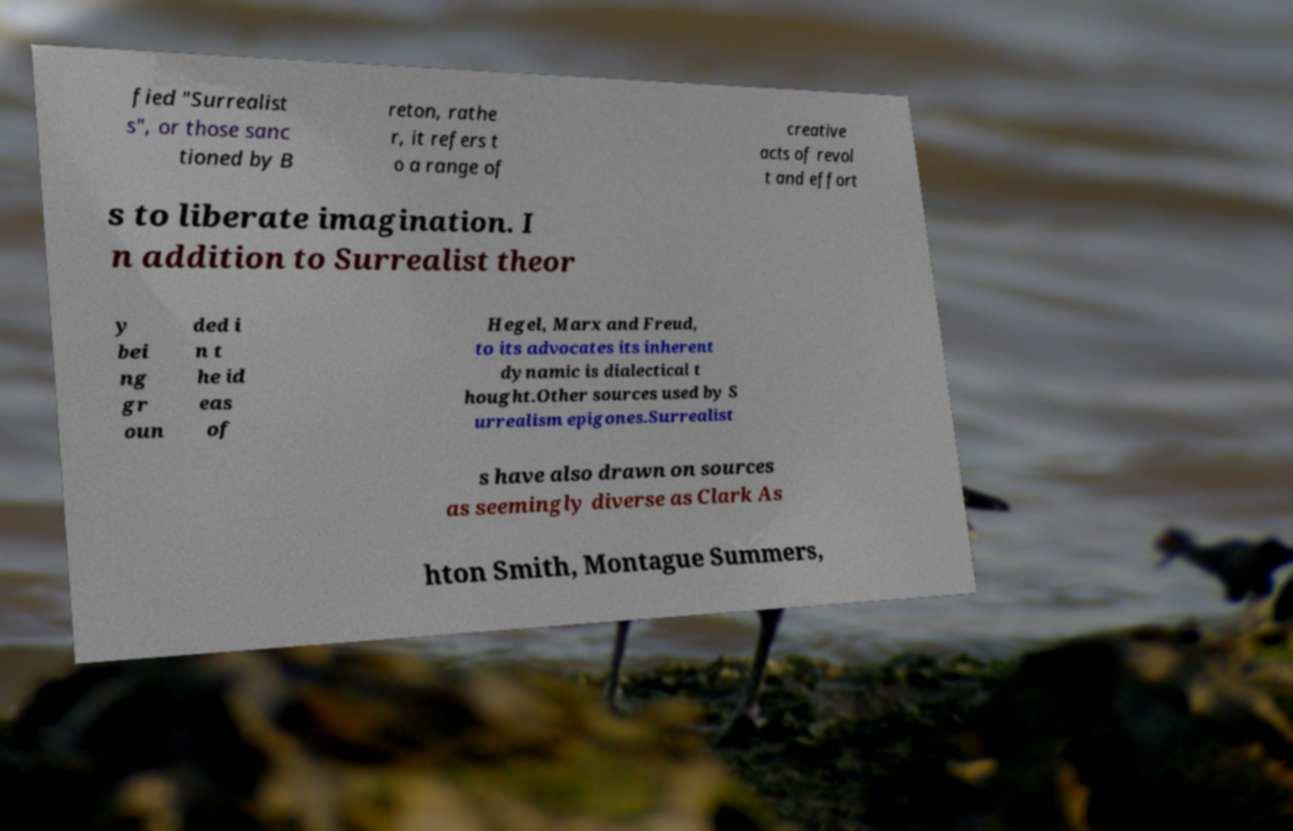There's text embedded in this image that I need extracted. Can you transcribe it verbatim? fied "Surrealist s", or those sanc tioned by B reton, rathe r, it refers t o a range of creative acts of revol t and effort s to liberate imagination. I n addition to Surrealist theor y bei ng gr oun ded i n t he id eas of Hegel, Marx and Freud, to its advocates its inherent dynamic is dialectical t hought.Other sources used by S urrealism epigones.Surrealist s have also drawn on sources as seemingly diverse as Clark As hton Smith, Montague Summers, 